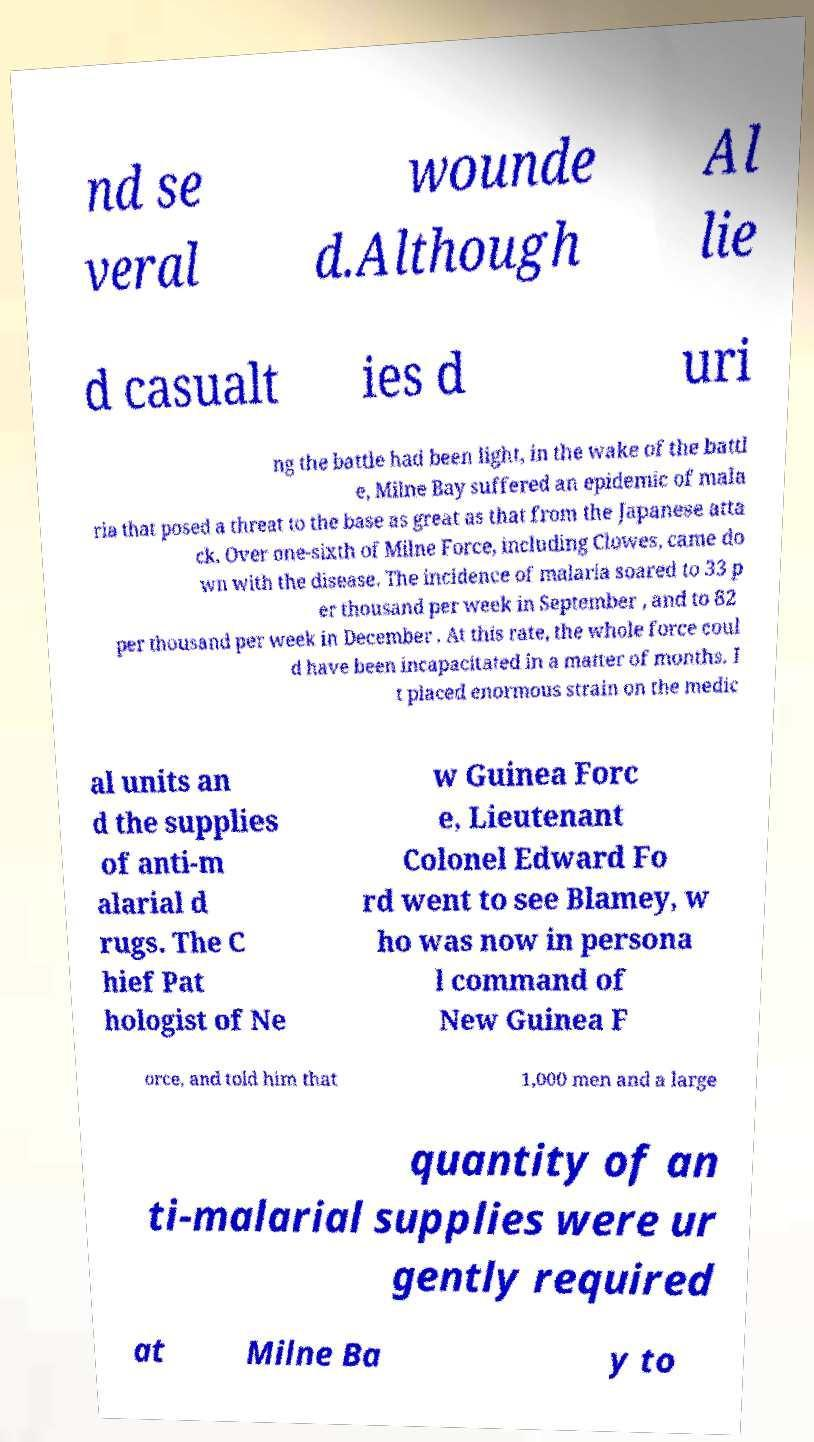Please identify and transcribe the text found in this image. nd se veral wounde d.Although Al lie d casualt ies d uri ng the battle had been light, in the wake of the battl e, Milne Bay suffered an epidemic of mala ria that posed a threat to the base as great as that from the Japanese atta ck. Over one-sixth of Milne Force, including Clowes, came do wn with the disease. The incidence of malaria soared to 33 p er thousand per week in September , and to 82 per thousand per week in December . At this rate, the whole force coul d have been incapacitated in a matter of months. I t placed enormous strain on the medic al units an d the supplies of anti-m alarial d rugs. The C hief Pat hologist of Ne w Guinea Forc e, Lieutenant Colonel Edward Fo rd went to see Blamey, w ho was now in persona l command of New Guinea F orce, and told him that 1,000 men and a large quantity of an ti-malarial supplies were ur gently required at Milne Ba y to 